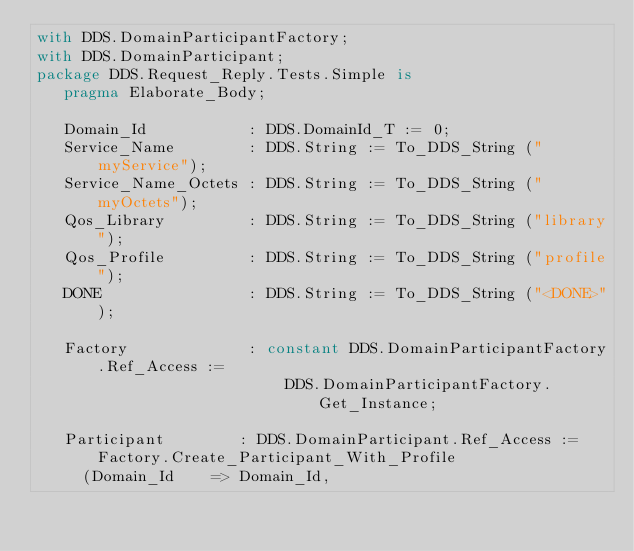<code> <loc_0><loc_0><loc_500><loc_500><_Ada_>with DDS.DomainParticipantFactory;
with DDS.DomainParticipant;
package DDS.Request_Reply.Tests.Simple is
   pragma Elaborate_Body;

   Domain_Id           : DDS.DomainId_T := 0;
   Service_Name        : DDS.String := To_DDS_String ("myService");
   Service_Name_Octets : DDS.String := To_DDS_String ("myOctets");
   Qos_Library         : DDS.String := To_DDS_String ("library");
   Qos_Profile         : DDS.String := To_DDS_String ("profile");
   DONE                : DDS.String := To_DDS_String ("<DONE>");

   Factory             : constant DDS.DomainParticipantFactory.Ref_Access :=
                           DDS.DomainParticipantFactory.Get_Instance;

   Participant        : DDS.DomainParticipant.Ref_Access := Factory.Create_Participant_With_Profile
     (Domain_Id    => Domain_Id,</code> 